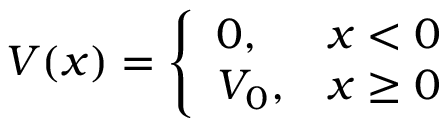<formula> <loc_0><loc_0><loc_500><loc_500>V ( x ) = { \left \{ \begin{array} { l l } { 0 , } & { x < 0 } \\ { V _ { 0 } , } & { x \geq 0 } \end{array} }</formula> 